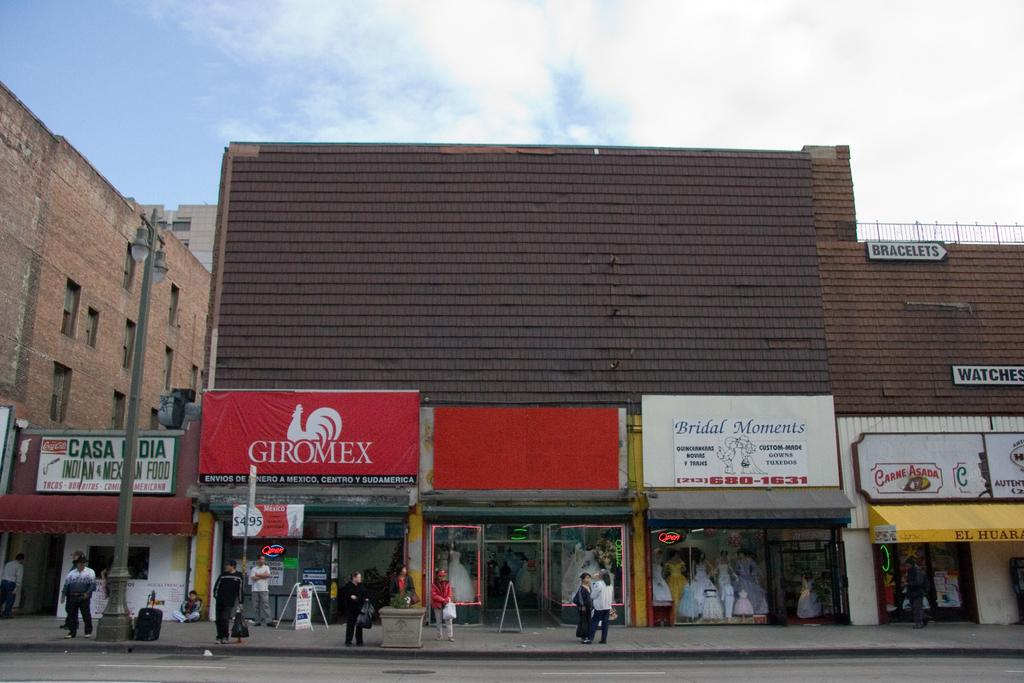How many people are in the image? There is a group of people in the image, but the exact number is not specified. Where are the people standing in the image? The people are standing on a footpath in the image. What can be seen in the background of the image? There are buildings visible in the image. What is visible above the people and buildings in the image? The sky is visible in the image. What type of instrument is being played by the duck in the image? There is no duck or instrument present in the image. 